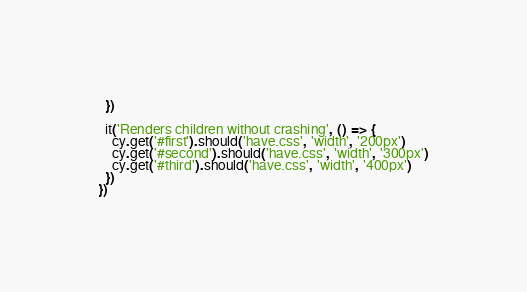<code> <loc_0><loc_0><loc_500><loc_500><_JavaScript_>  })

  it('Renders children without crashing', () => {
    cy.get('#first').should('have.css', 'width', '200px')
    cy.get('#second').should('have.css', 'width', '300px')
    cy.get('#third').should('have.css', 'width', '400px')
  })
})
</code> 